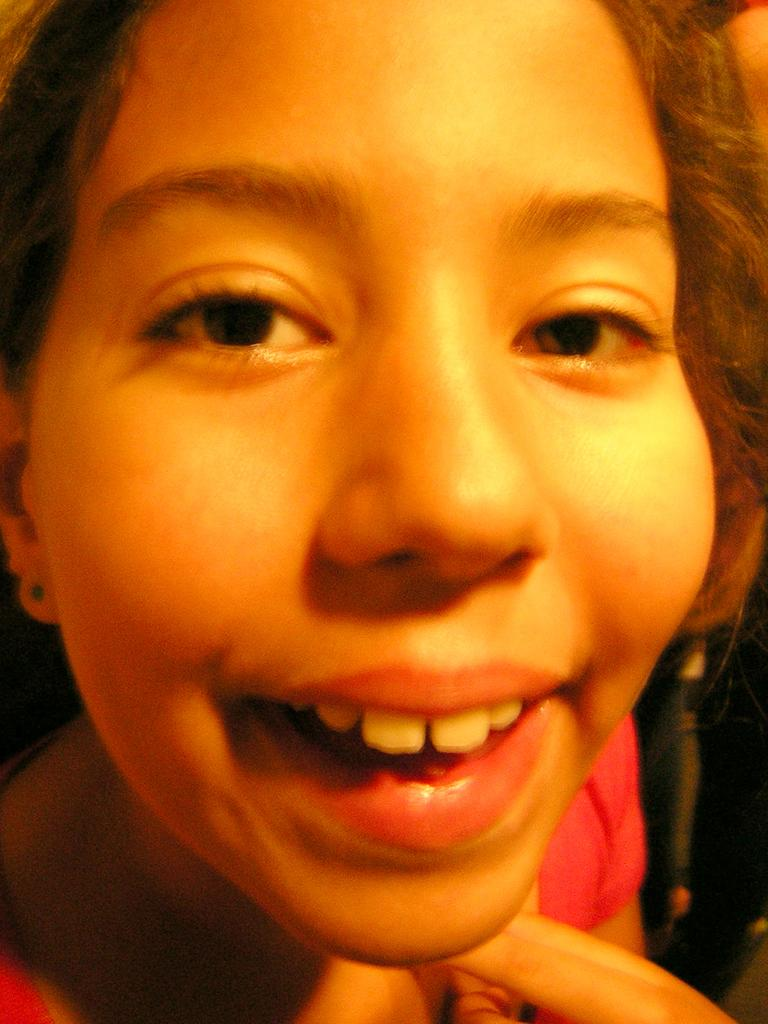What is the main focus of the image? The main focus of the image is a girl's face. Where is the girl's face located in the image? The girl's face is in the middle of the image. What type of cart is the girl pushing in the image? There is no cart present in the image; it is a zoom-in of the girl's face. 